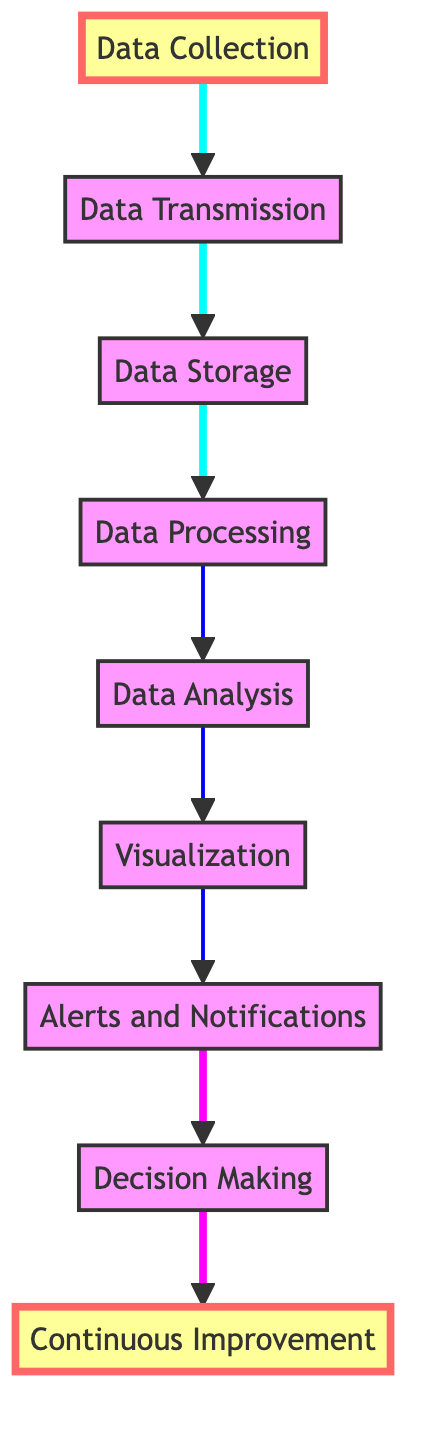What is the first step in the process? The first step shown in the flow chart is "Data Collection," which serves as the starting point for managing utility usage.
Answer: Data Collection How many nodes are present in the diagram? By counting the distinct elements listed in the diagram, there are a total of 9 nodes, ranging from data collection to continuous improvement.
Answer: 9 What step comes before Data Analysis? According to the flow, the step immediately preceding Data Analysis is Data Processing. This means that data must be processed before any analysis can occur.
Answer: Data Processing Which step directly follows Visualization? The step that comes right after Visualization is Alerts and Notifications, indicating that once data is visualized, alerts can be triggered based on the insights gained.
Answer: Alerts and Notifications What is the relationship between Data Analysis and Decision Making? The relationship is that Data Analysis provides insights that feed into Decision Making. Thus, efficient analysis informs and enhances the decisions urban planners and managers can make.
Answer: Insights feeding into Decision Making What do the automated alerts indicate? The automated alerts and notifications indicate anomalies or irregularities detected within the utility usage data. This is crucial for timely response and management.
Answer: Anomalies or irregularities What is the purpose of the Continuous Improvement step? Continuous Improvement serves as a feedback loop meant to enhance urban utility management strategies through ongoing monitoring and evaluation of collected data.
Answer: Feedback loop for enhancement Which technology is used for real-time data processing? The technologies mentioned in the diagram for processing collected data in real-time are Apache Kafka and Apache Spark, both being critical for handling big data streams efficiently.
Answer: Apache Kafka and Apache Spark 